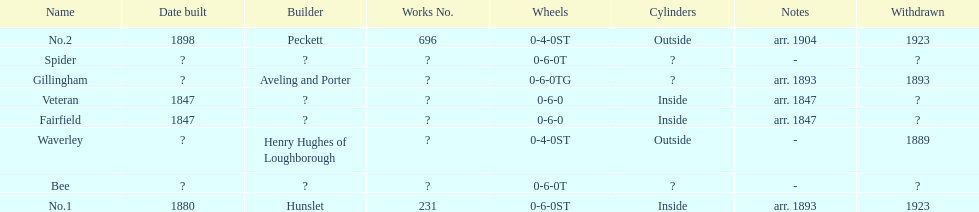Were there more with inside or outside cylinders? Inside. 